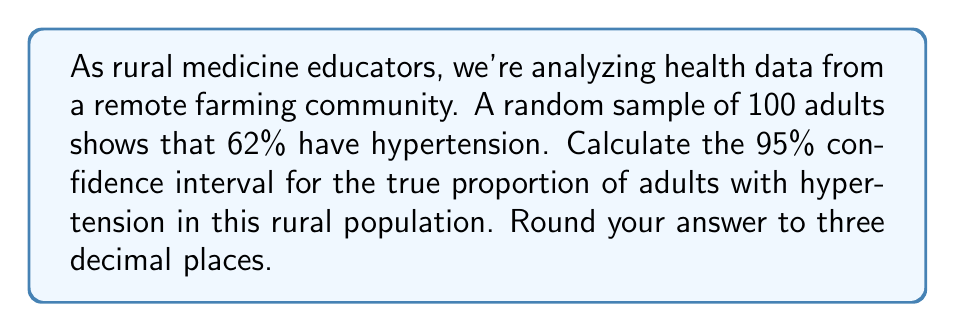Teach me how to tackle this problem. Let's approach this step-by-step:

1) We're dealing with a proportion, so we'll use the formula for the confidence interval of a proportion:

   $$p \pm z\sqrt{\frac{p(1-p)}{n}}$$

   Where:
   $p$ = sample proportion
   $z$ = z-score for desired confidence level
   $n$ = sample size

2) We know:
   $p = 0.62$ (62% = 0.62)
   $n = 100$
   For a 95% confidence interval, $z = 1.96$

3) Let's substitute these values into our formula:

   $$0.62 \pm 1.96\sqrt{\frac{0.62(1-0.62)}{100}}$$

4) Simplify inside the square root:

   $$0.62 \pm 1.96\sqrt{\frac{0.62(0.38)}{100}}$$

5) Calculate:

   $$0.62 \pm 1.96\sqrt{\frac{0.2356}{100}} = 0.62 \pm 1.96\sqrt{0.002356}$$

   $$0.62 \pm 1.96(0.0485) = 0.62 \pm 0.09506$$

6) Therefore, the confidence interval is:

   $$0.62 - 0.09506 \text{ to } 0.62 + 0.09506$$
   $$0.52494 \text{ to } 0.71506$$

7) Rounding to three decimal places:

   $$0.525 \text{ to } 0.715$$
Answer: (0.525, 0.715) 